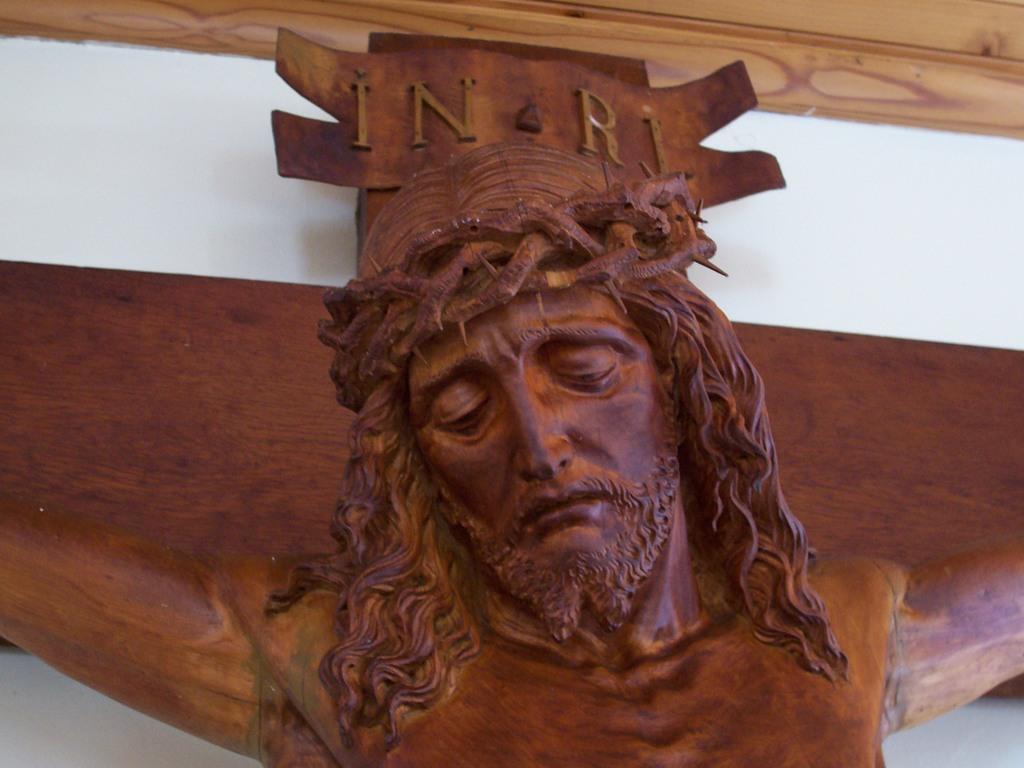Could you give a brief overview of what you see in this image? In this image we can see a wooden statue on the wall. 